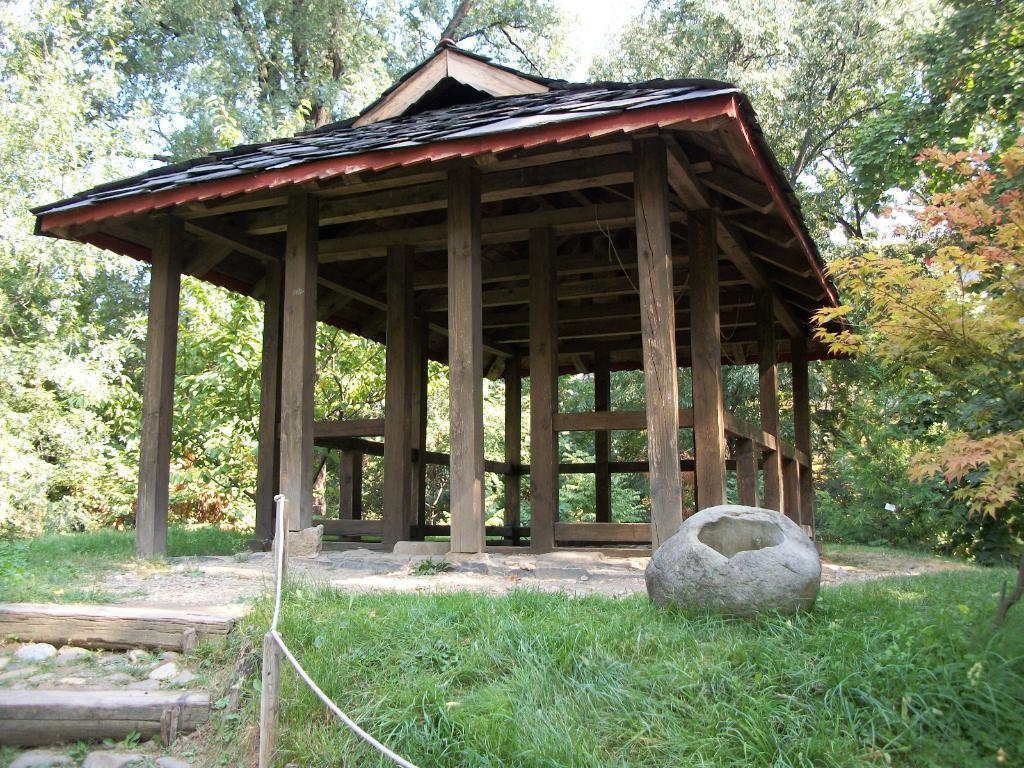What is located in the foreground of the image? There is a staircase, grass, a rope, a rock, wooden poles, and a wooden construction in the foreground of the image. What type of vegetation can be seen in the foreground of the image? Grass is present in the foreground of the image. What objects are associated with the wooden construction in the foreground? The wooden construction has a rope and wooden poles associated with it. What can be seen in the background of the image? There are trees, plants, and the sky visible in the background of the image. How many bikes are parked near the wooden construction in the image? There are no bikes present in the image. What type of church can be seen in the background of the image? There is no church present in the image; only trees, plants, and the sky are visible in the background. 